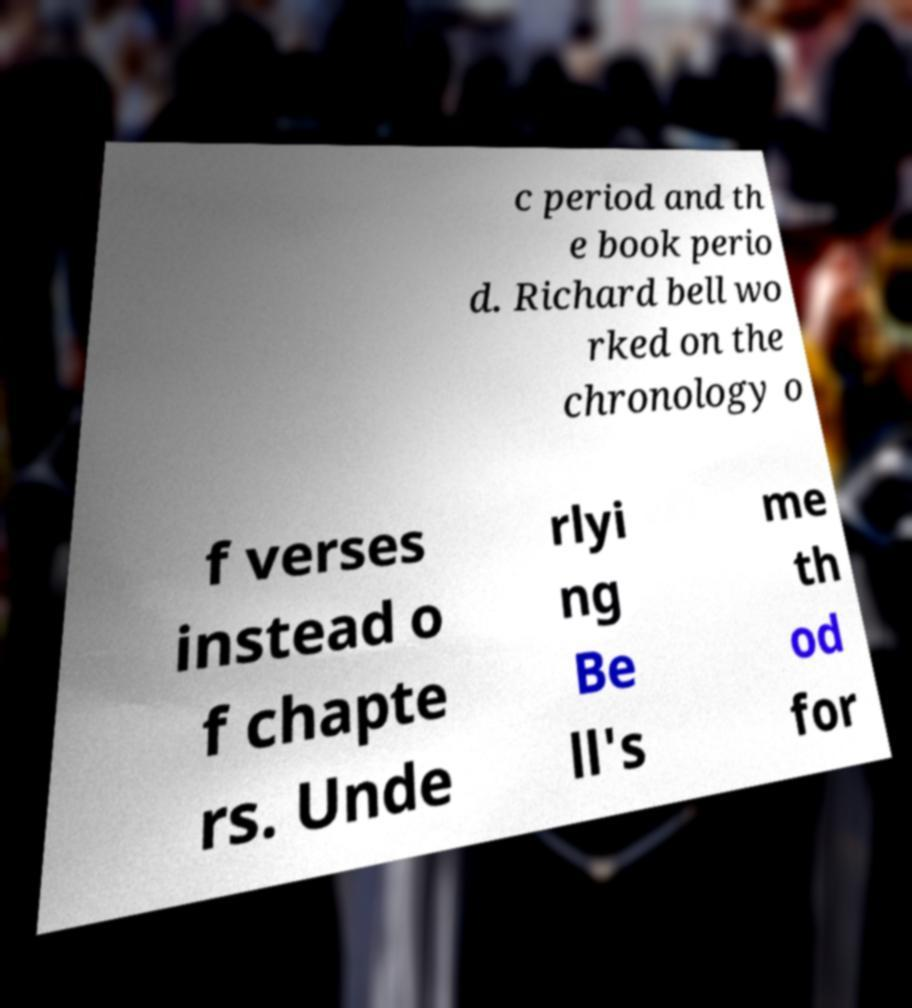Please identify and transcribe the text found in this image. c period and th e book perio d. Richard bell wo rked on the chronology o f verses instead o f chapte rs. Unde rlyi ng Be ll's me th od for 